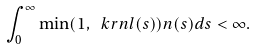Convert formula to latex. <formula><loc_0><loc_0><loc_500><loc_500>\int _ { 0 } ^ { \infty } \min ( 1 , \ k r n l ( s ) ) n ( s ) d s < \infty .</formula> 